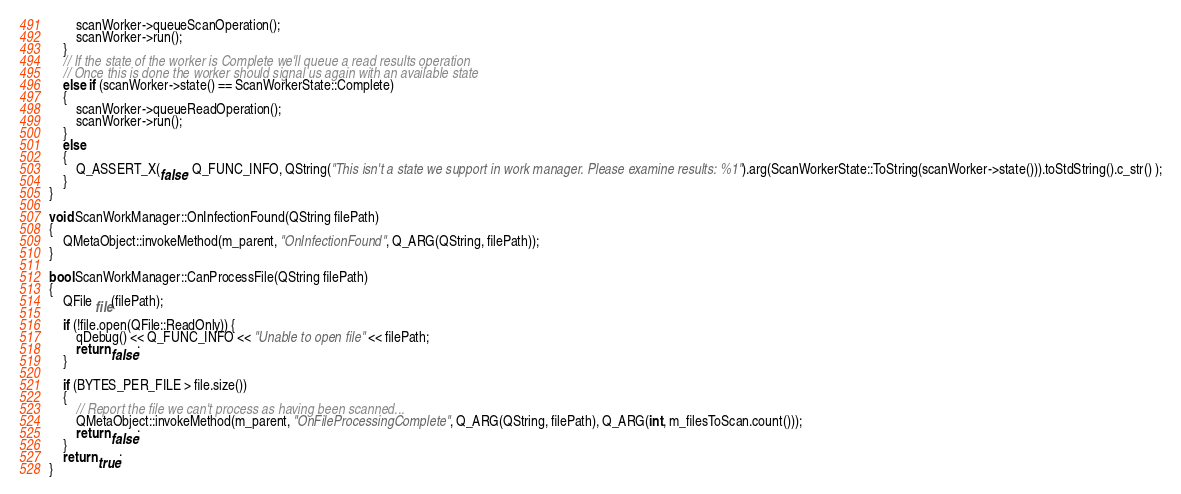<code> <loc_0><loc_0><loc_500><loc_500><_C++_>        scanWorker->queueScanOperation();
        scanWorker->run();
    }
    // If the state of the worker is Complete we'll queue a read results operation
    // Once this is done the worker should signal us again with an available state
    else if (scanWorker->state() == ScanWorkerState::Complete)
    {
        scanWorker->queueReadOperation();
        scanWorker->run();
    }
    else
    {
        Q_ASSERT_X(false, Q_FUNC_INFO, QString("This isn't a state we support in work manager. Please examine results: %1").arg(ScanWorkerState::ToString(scanWorker->state())).toStdString().c_str() );
    }
}

void ScanWorkManager::OnInfectionFound(QString filePath)
{
    QMetaObject::invokeMethod(m_parent, "OnInfectionFound", Q_ARG(QString, filePath));
}

bool ScanWorkManager::CanProcessFile(QString filePath)
{
    QFile file(filePath);
    
    if (!file.open(QFile::ReadOnly)) {
        qDebug() << Q_FUNC_INFO << "Unable to open file" << filePath;
        return false;
    }

    if (BYTES_PER_FILE > file.size())
    {
        // Report the file we can't process as having been scanned...
        QMetaObject::invokeMethod(m_parent, "OnFileProcessingComplete", Q_ARG(QString, filePath), Q_ARG(int, m_filesToScan.count()));
        return false;
    }
    return true;
}</code> 